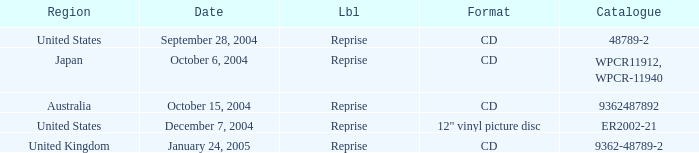Can you parse all the data within this table? {'header': ['Region', 'Date', 'Lbl', 'Format', 'Catalogue'], 'rows': [['United States', 'September 28, 2004', 'Reprise', 'CD', '48789-2'], ['Japan', 'October 6, 2004', 'Reprise', 'CD', 'WPCR11912, WPCR-11940'], ['Australia', 'October 15, 2004', 'Reprise', 'CD', '9362487892'], ['United States', 'December 7, 2004', 'Reprise', '12" vinyl picture disc', 'ER2002-21'], ['United Kingdom', 'January 24, 2005', 'Reprise', 'CD', '9362-48789-2']]} Name the region for december 7, 2004 United States. 